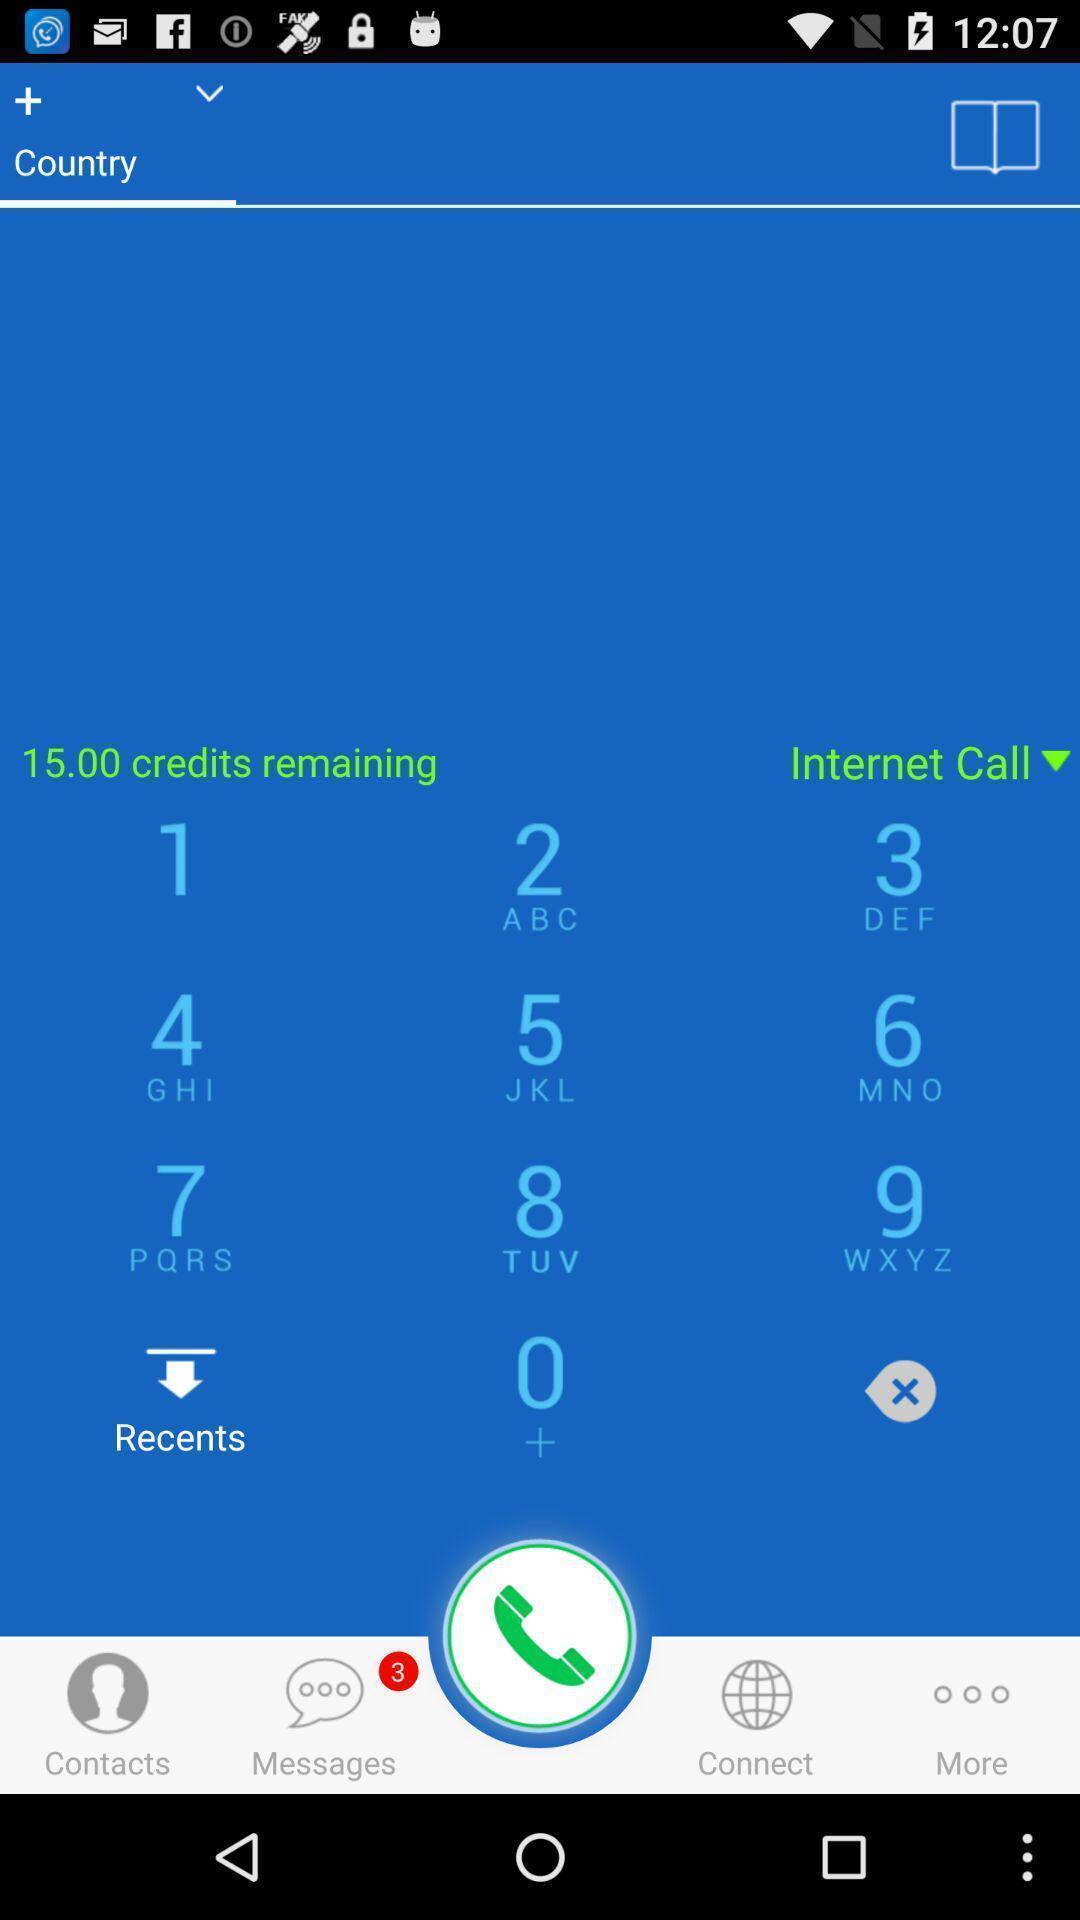Describe the key features of this screenshot. Page displaying the details of numbers. 